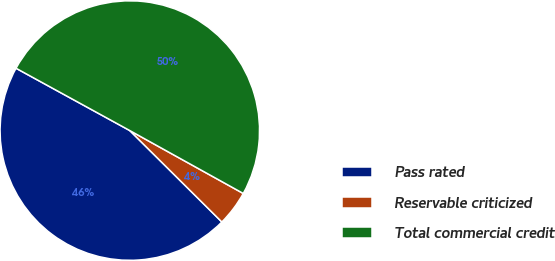Convert chart. <chart><loc_0><loc_0><loc_500><loc_500><pie_chart><fcel>Pass rated<fcel>Reservable criticized<fcel>Total commercial credit<nl><fcel>45.53%<fcel>4.39%<fcel>50.08%<nl></chart> 